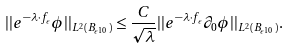<formula> <loc_0><loc_0><loc_500><loc_500>| | e ^ { - \lambda \cdot f _ { \epsilon } } \phi | | _ { L ^ { 2 } ( B _ { \epsilon ^ { 1 0 } } ) } \leq \frac { C } { \sqrt { \lambda } } | | e ^ { - \lambda \cdot f _ { \epsilon } } \partial _ { 0 } \phi | | _ { L ^ { 2 } ( B _ { \epsilon ^ { 1 0 } } ) } .</formula> 